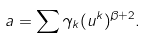Convert formula to latex. <formula><loc_0><loc_0><loc_500><loc_500>a = \sum \gamma _ { k } ( u ^ { k } ) ^ { \beta + 2 } .</formula> 